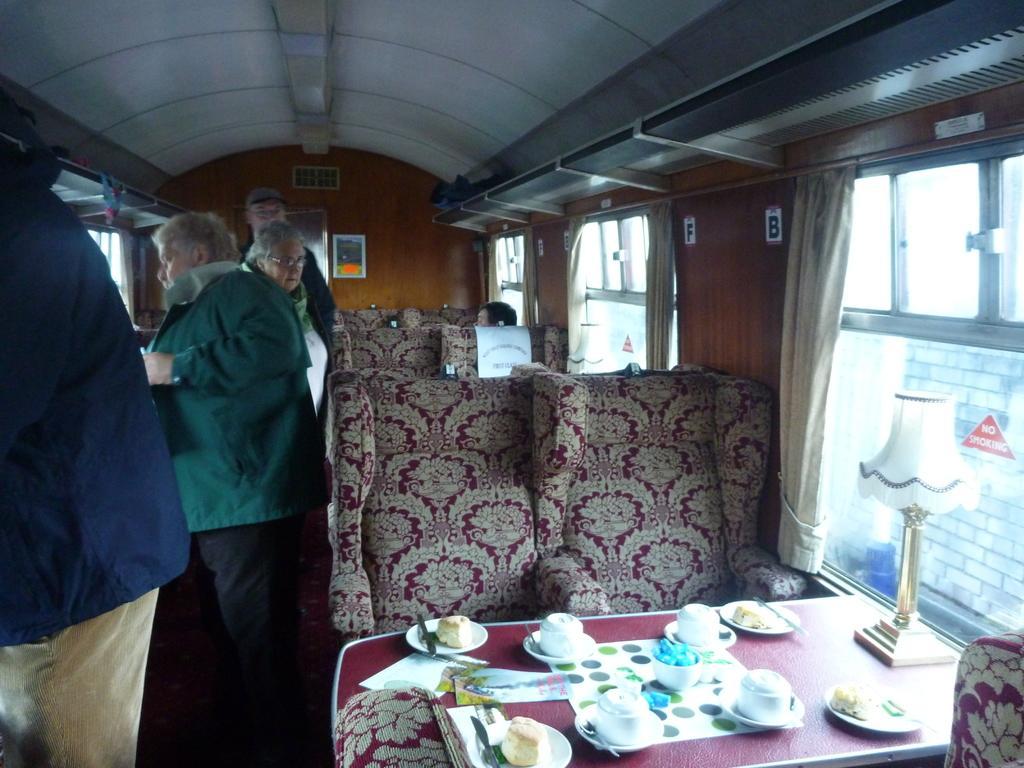How would you summarize this image in a sentence or two? In the picture we can see inside view of the restaurant with chairs and tables and on the table, we can see the cup and saucers, plates and a lamp and beside it, we can see the windows with glasses and the curtains to it and beside it we can see some people are standing. 